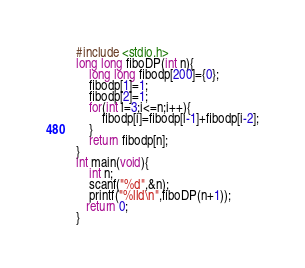Convert code to text. <code><loc_0><loc_0><loc_500><loc_500><_C_>#include <stdio.h>
long long fiboDP(int n){
    long long fibodp[200]={0};
    fibodp[1]=1;
    fibodp[2]=1;
    for(int i=3;i<=n;i++){
        fibodp[i]=fibodp[i-1]+fibodp[i-2];
    }
    return fibodp[n];
}
int main(void){
    int n;
    scanf("%d",&n);
    printf("%lld\n",fiboDP(n+1));
   return 0;
}
</code> 